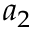<formula> <loc_0><loc_0><loc_500><loc_500>a _ { 2 }</formula> 